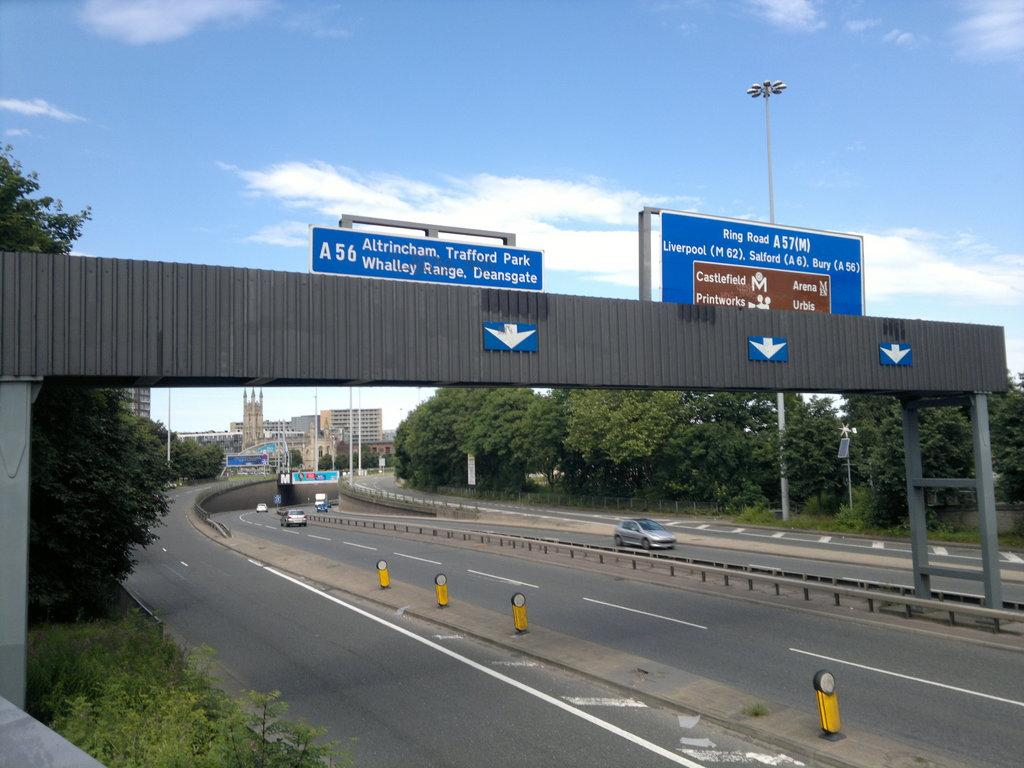<image>
Present a compact description of the photo's key features. A freeway has a row of street signs above it and one says Altrincham Trafford Park. 